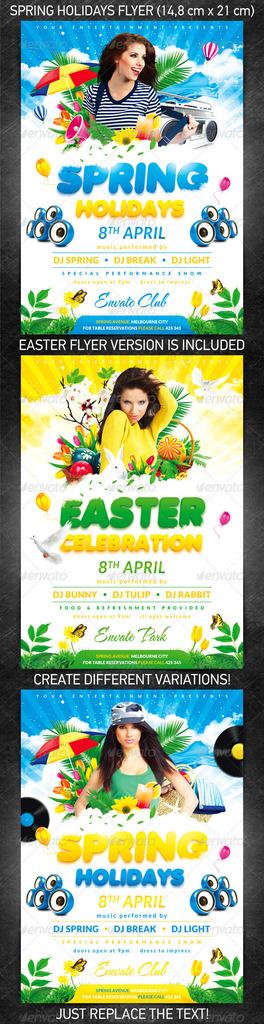Is this an ad for a movie?
Provide a succinct answer. No. What time does spring holidays release?
Ensure brevity in your answer.  April 8th. 